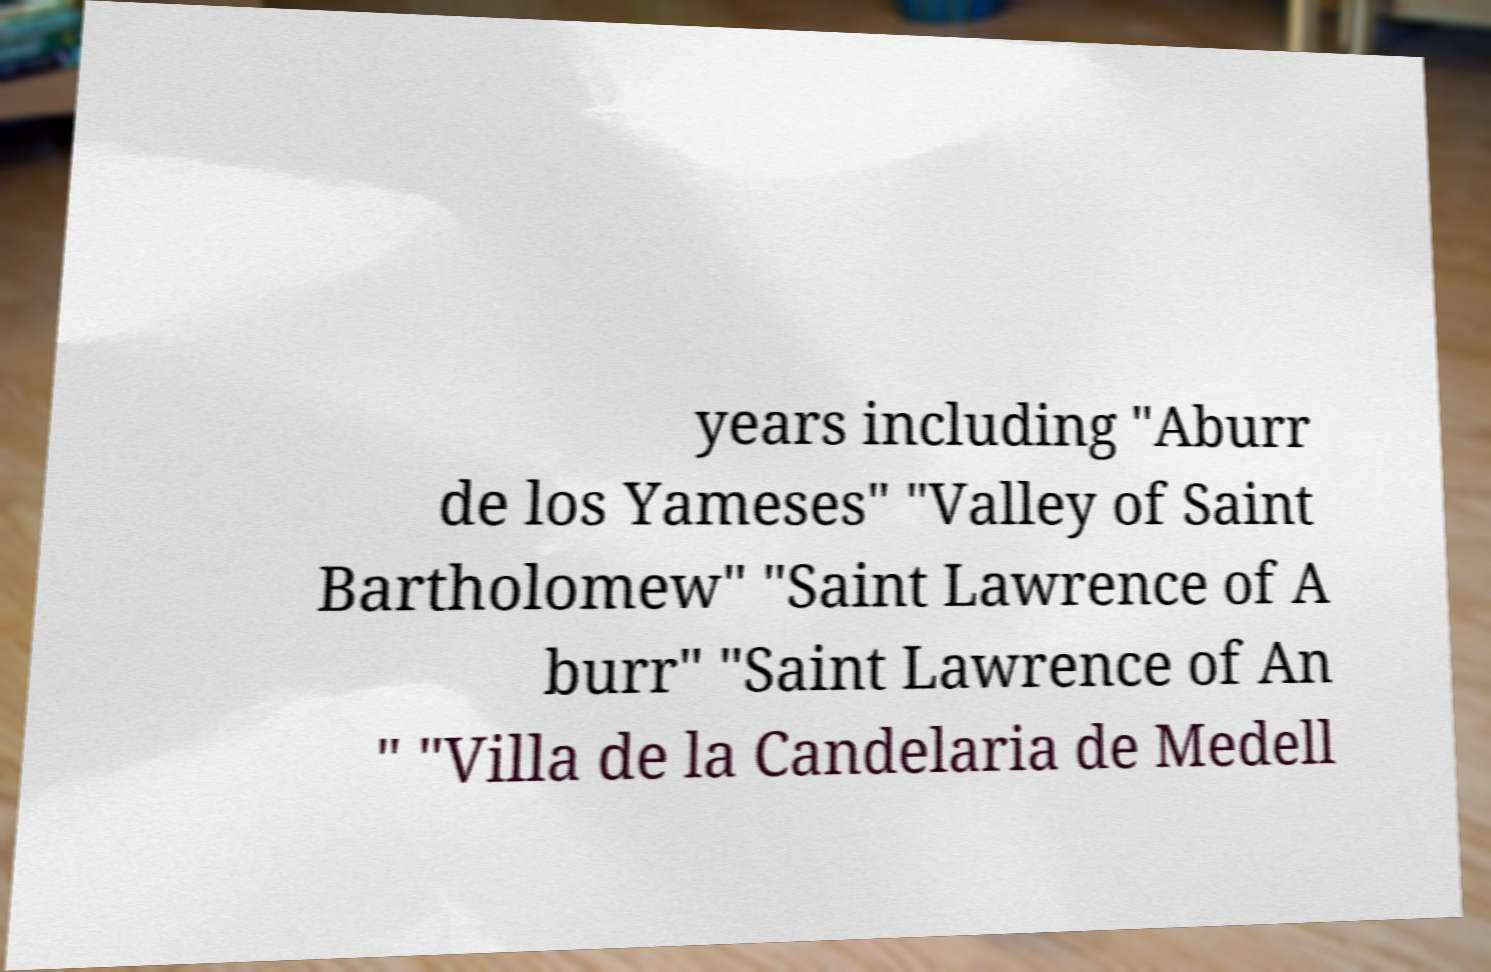Please identify and transcribe the text found in this image. years including "Aburr de los Yameses" "Valley of Saint Bartholomew" "Saint Lawrence of A burr" "Saint Lawrence of An " "Villa de la Candelaria de Medell 